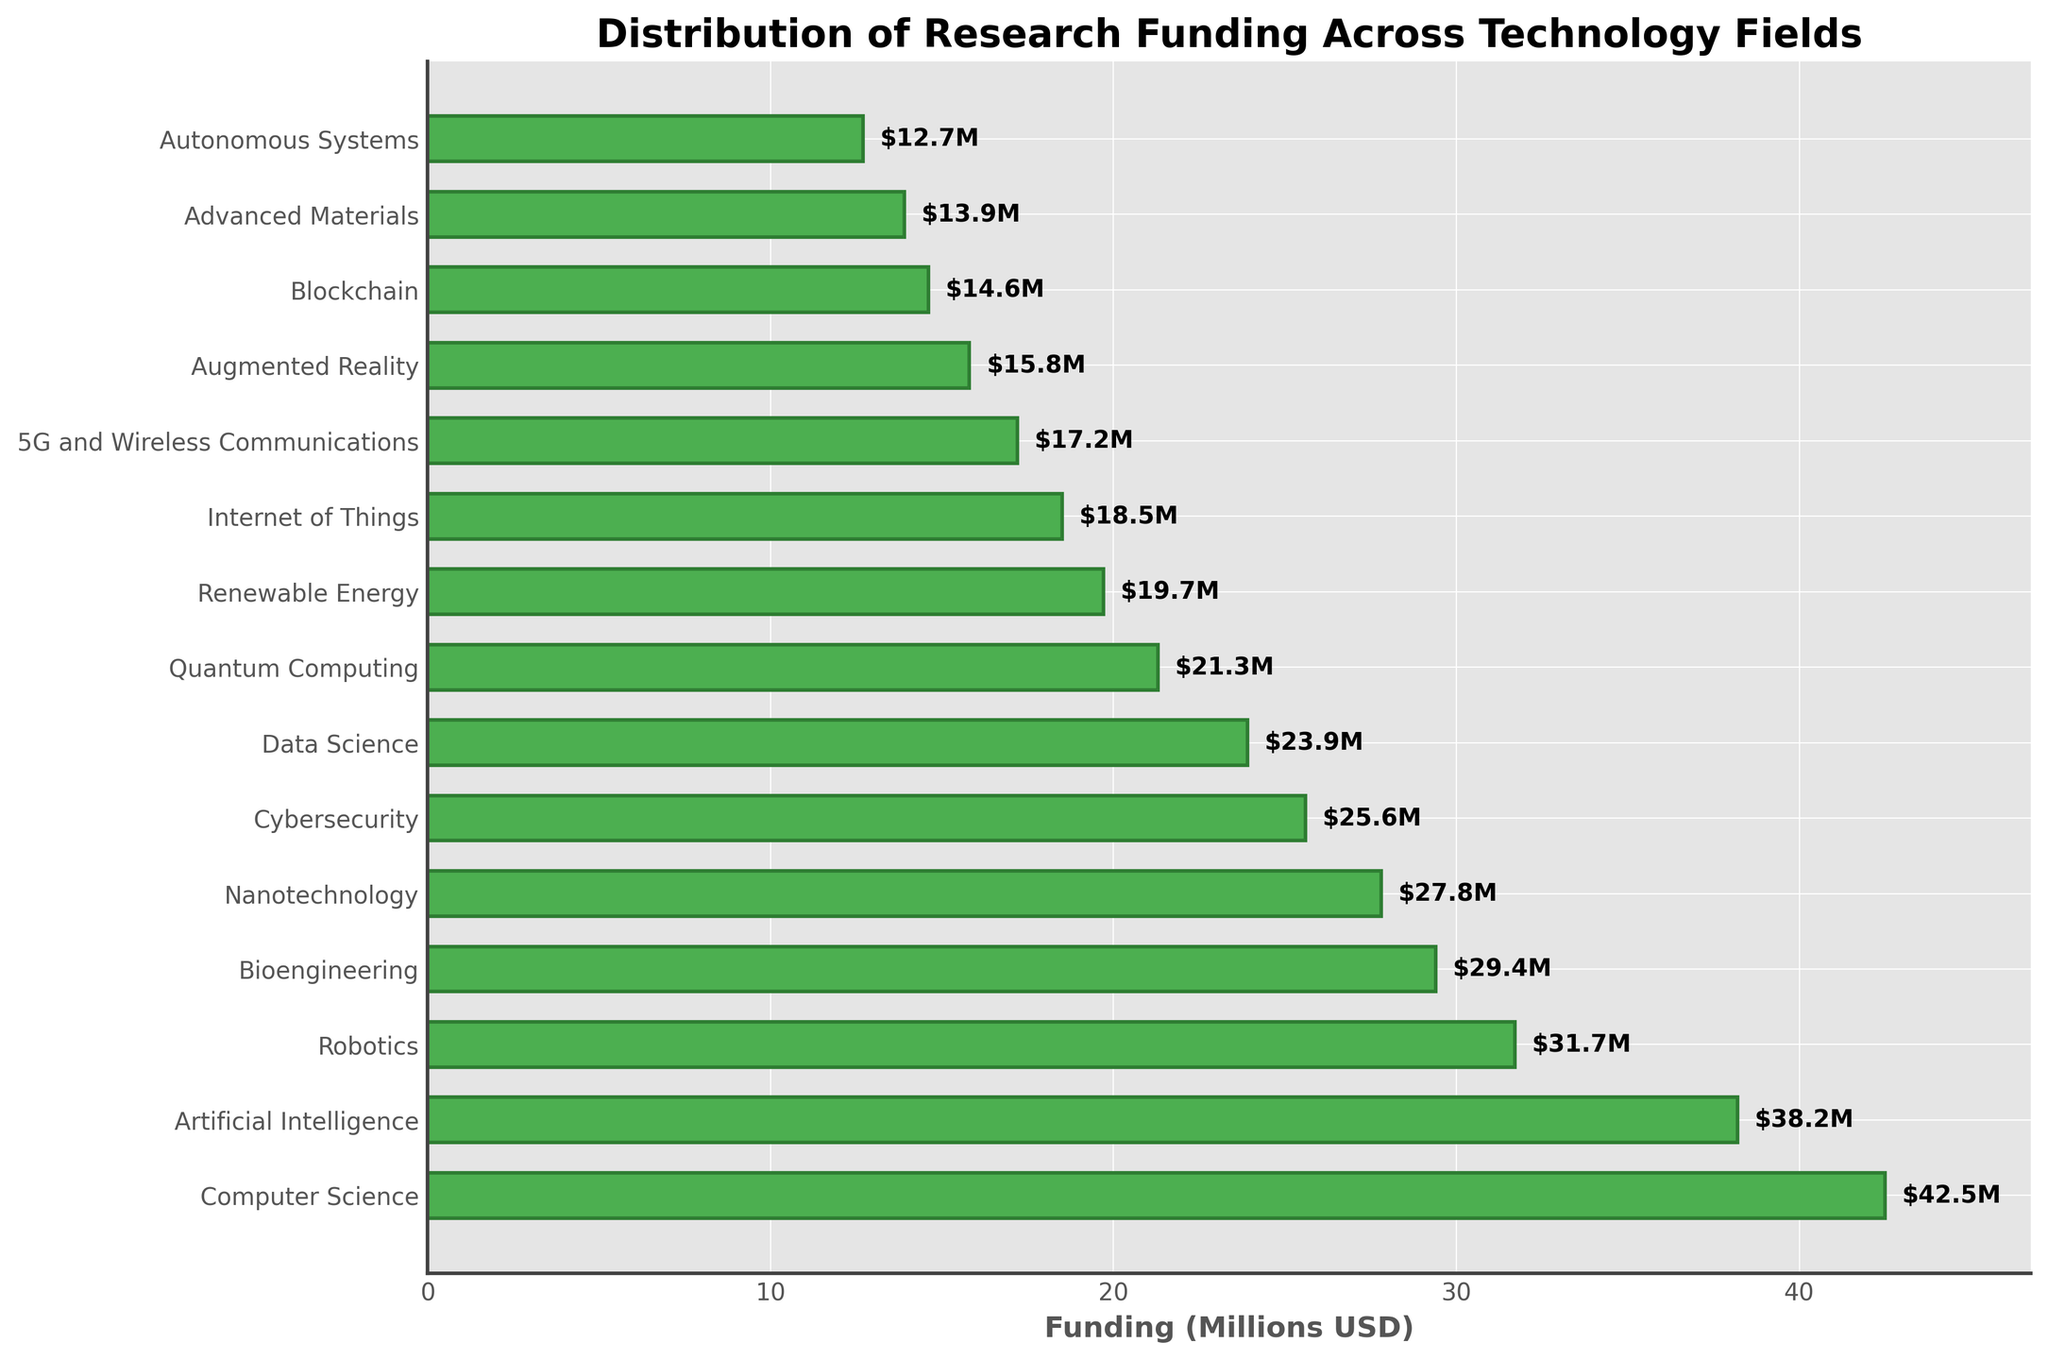Which field received the highest research funding? The field with the highest bar length received the most funding. Computer Science has the longest bar.
Answer: Computer Science What is the total funding for Artificial Intelligence and Robotics? Sum the funding amounts for Artificial Intelligence ($38.2M) and Robotics ($31.7M): 38.2 + 31.7.
Answer: $69.9M Which field received the lowest research funding? The field with the shortest bar received the least funding. Autonomous Systems has the shortest bar.
Answer: Autonomous Systems How much more funding did Computer Science receive compared to Cybersecurity? Subtract the funding for Cybersecurity ($25.6M) from the funding for Computer Science ($42.5M): 42.5 - 25.6.
Answer: $16.9M What is the average funding amount across all fields? Sum all funding amounts and divide by the number of fields. Total funding is 372.2M, divided by 15 fields: 372.2 / 15.
Answer: $24.81M Which fields had funding amounts less than $20 million? Identify bars with lengths representing funding < $20M: Renewable Energy, Internet of Things, 5G and Wireless Communications, Augmented Reality, Blockchain, Advanced Materials, Autonomous Systems.
Answer: Renewable Energy, Internet of Things, 5G and Wireless Communications, Augmented Reality, Blockchain, Advanced Materials, Autonomous Systems Is the funding for Bioengineering higher than for Quantum Computing? Compare the bar lengths for Bioengineering and Quantum Computing. Bioengineering ($29.4M) is greater than Quantum Computing ($21.3M).
Answer: Yes What is the difference in funding between the top two categories? Subtract the funding amounts for Artificial Intelligence ($38.2M) from Computer Science ($42.5M): 42.5 - 38.2.
Answer: $4.3M What percent of the total funding does Data Science represent? Divide Data Science funding ($23.9M) by the total funding ($372.2M) and multiply by 100: (23.9 / 372.2) * 100.
Answer: 6.42% Which fields received more funding than Nanotechnology? Identify fields with longer bars (higher funding) than Nanotechnology ($27.8M): Computer Science, Artificial Intelligence, Robotics, Bioengineering.
Answer: Computer Science, Artificial Intelligence, Robotics, Bioengineering 